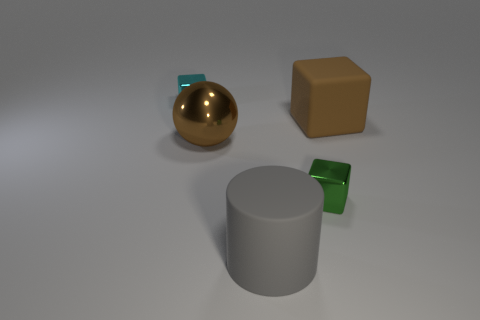Add 3 big matte cubes. How many objects exist? 8 Subtract all cubes. How many objects are left? 2 Add 1 green metallic objects. How many green metallic objects are left? 2 Add 2 big matte cylinders. How many big matte cylinders exist? 3 Subtract 0 yellow cubes. How many objects are left? 5 Subtract all metallic balls. Subtract all small gray cylinders. How many objects are left? 4 